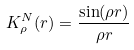<formula> <loc_0><loc_0><loc_500><loc_500>K _ { \rho } ^ { N } ( r ) = \frac { \sin ( \rho r ) } { \rho r }</formula> 